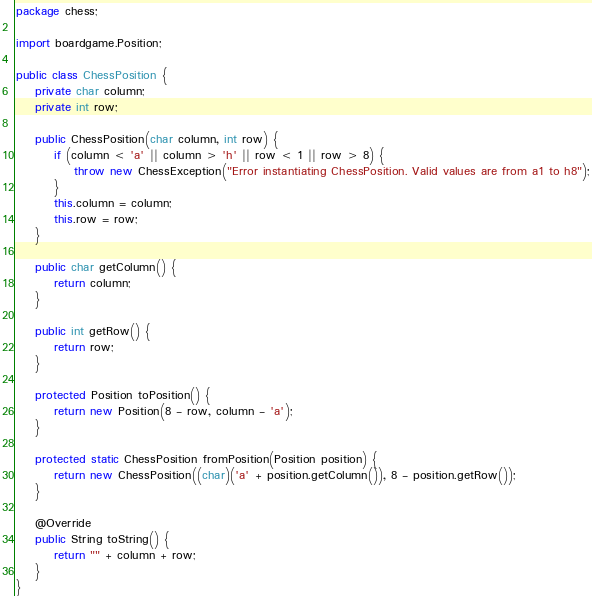<code> <loc_0><loc_0><loc_500><loc_500><_Java_>package chess;

import boardgame.Position;

public class ChessPosition {
	private char column;
	private int row;
	
	public ChessPosition(char column, int row) {
		if (column < 'a' || column > 'h' || row < 1 || row > 8) {
			throw new ChessException("Error instantiating ChessPosition. Valid values are from a1 to h8");
		}
		this.column = column;
		this.row = row;
	}

	public char getColumn() {
		return column;
	}

	public int getRow() {
		return row;
	}
	
	protected Position toPosition() {
		return new Position(8 - row, column - 'a');
	}
	
	protected static ChessPosition fromPosition(Position position) {
		return new ChessPosition((char)('a' + position.getColumn()), 8 - position.getRow());
	}
	
	@Override
	public String toString() {
		return "" + column + row;
	}
}
</code> 